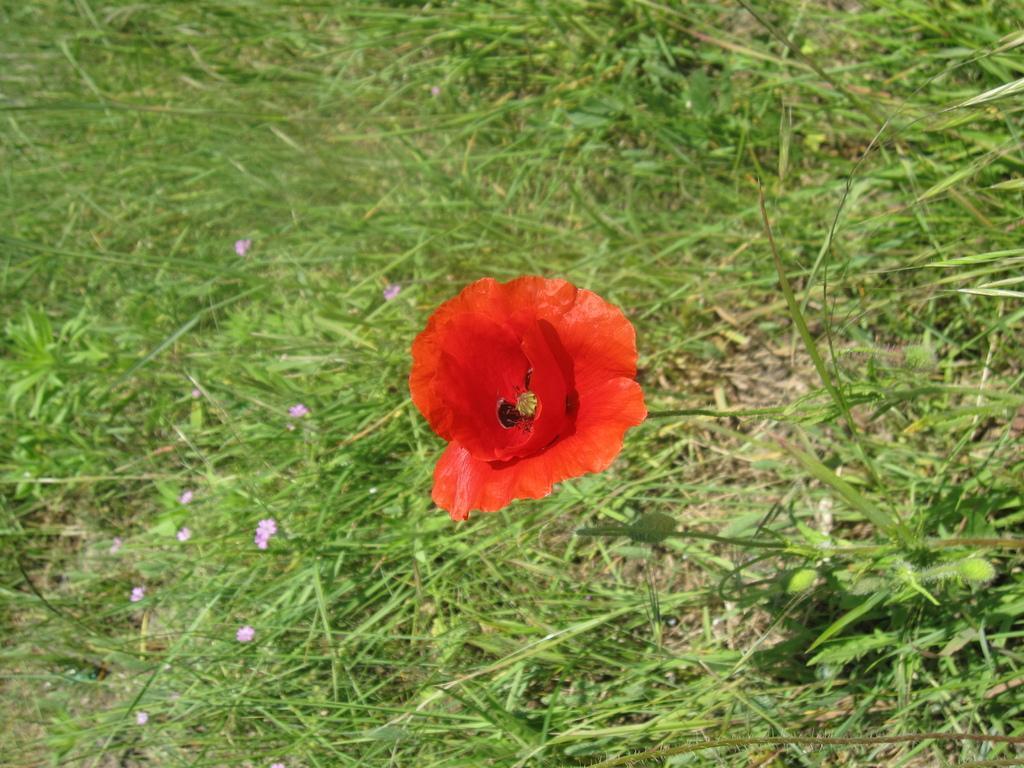Could you give a brief overview of what you see in this image? In this picture there is a red color flower in the center of the image and there is greenery around the area of the image. 